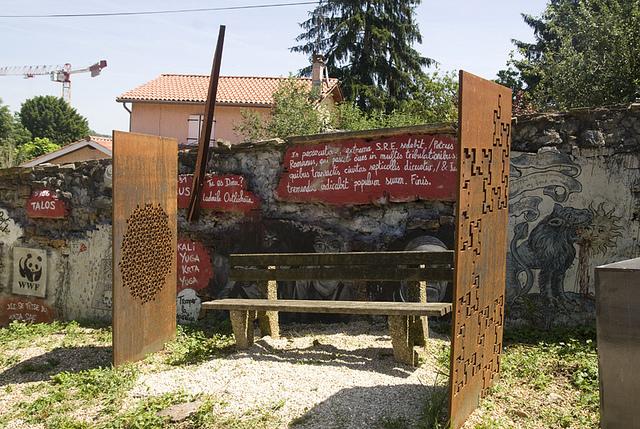What color is the sign?
Write a very short answer. Red. What is between the two support walls?
Answer briefly. Bench. What is the bench made of?
Answer briefly. Wood. 